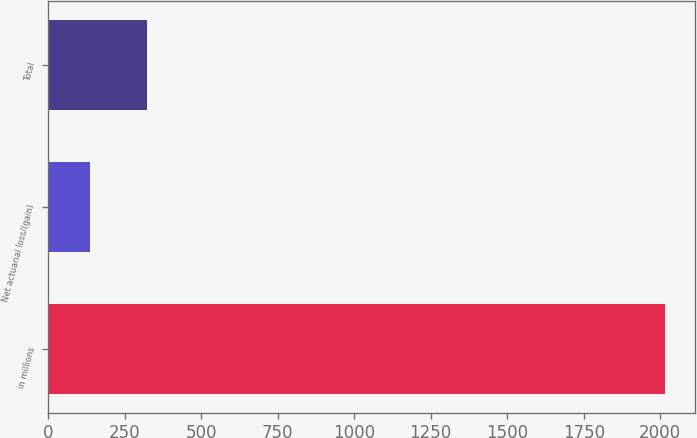Convert chart. <chart><loc_0><loc_0><loc_500><loc_500><bar_chart><fcel>in millions<fcel>Net actuarial loss/(gain)<fcel>Total<nl><fcel>2014<fcel>136.5<fcel>324.25<nl></chart> 